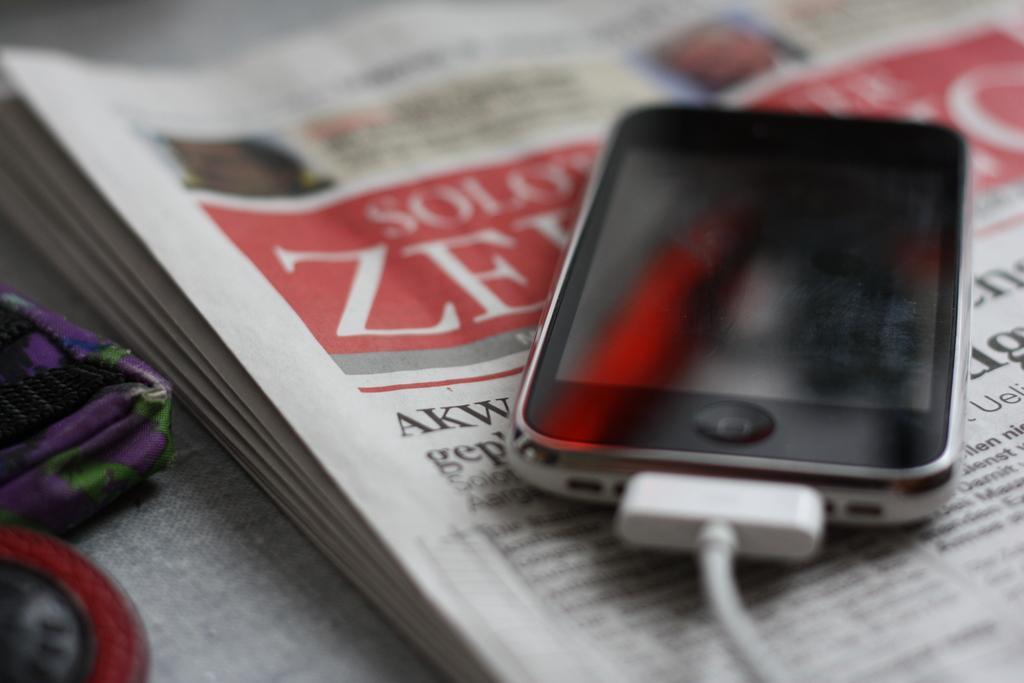How would you summarize this image in a sentence or two? This image is taken indoors. At the bottom of the image there is a table with a tablecloth, a pouch, a newspaper and a mobile phone with a charger on it. 